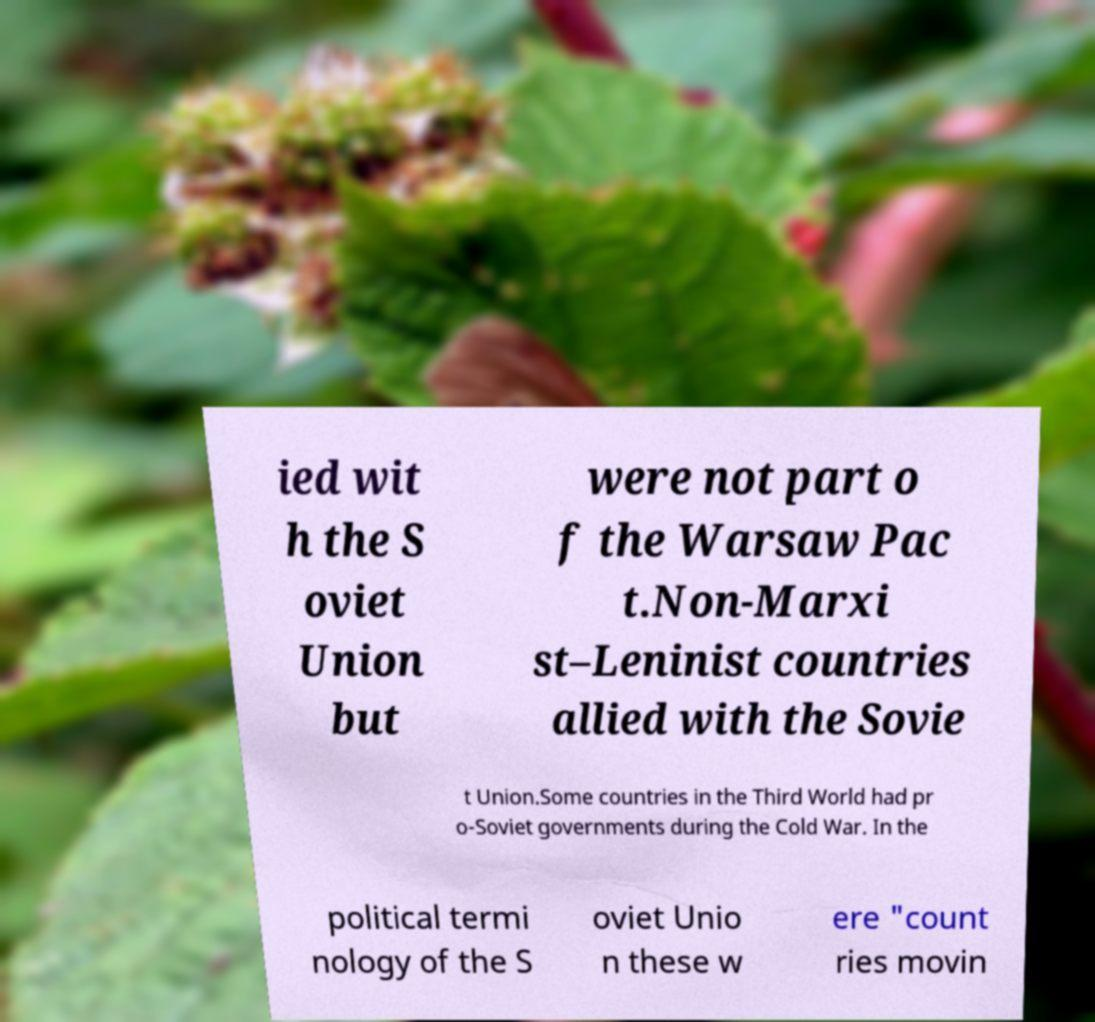Please read and relay the text visible in this image. What does it say? ied wit h the S oviet Union but were not part o f the Warsaw Pac t.Non-Marxi st–Leninist countries allied with the Sovie t Union.Some countries in the Third World had pr o-Soviet governments during the Cold War. In the political termi nology of the S oviet Unio n these w ere "count ries movin 